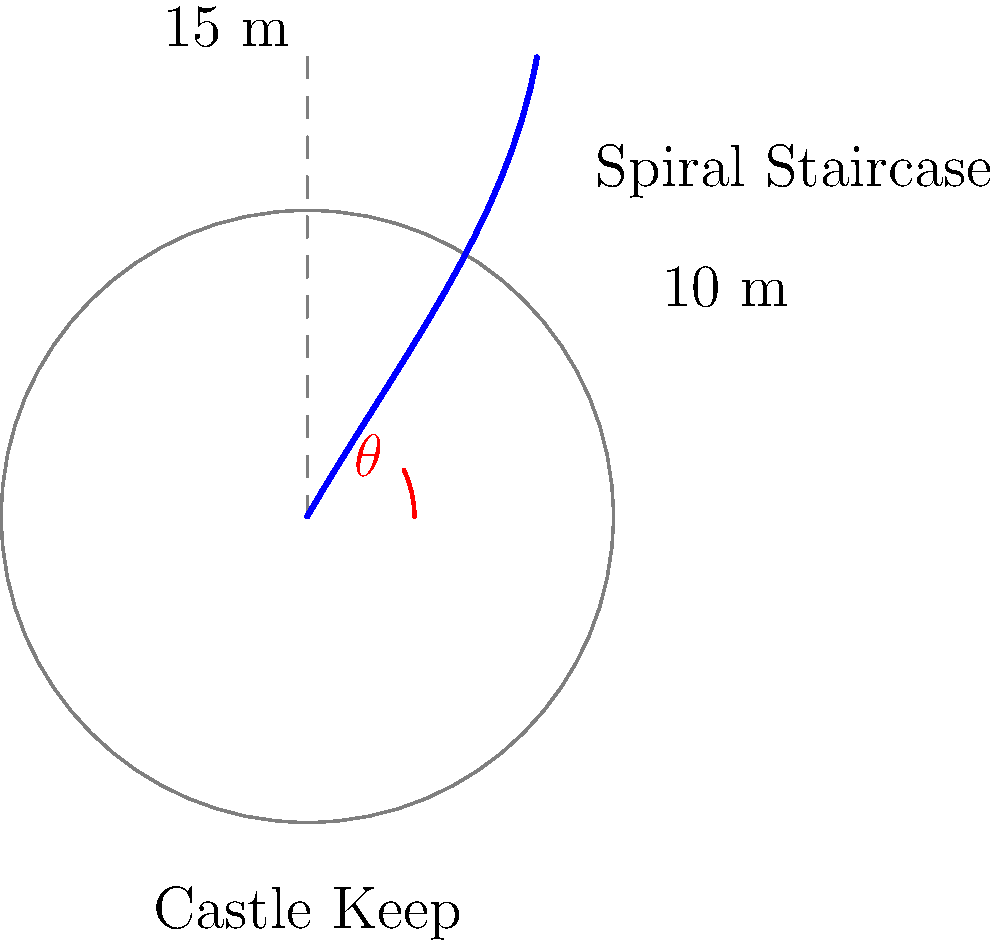In a medieval castle keep, a spiral staircase winds its way up to the top. The staircase makes one complete revolution around the circular keep, which has a circumference of 10 meters. If the height of the keep is 15 meters, what is the angle $\theta$ (in degrees) that the staircase makes with the horizontal plane? To solve this problem, we need to visualize the spiral staircase as if it were "unwound" into a right triangle. Let's approach this step-by-step:

1) In this right triangle:
   - The base represents the circumference of the keep (10 m)
   - The height represents the vertical distance (15 m)
   - The hypotenuse represents the unwound staircase
   - The angle $\theta$ is what we're looking for

2) We can use the arctangent function to find this angle. In a right triangle:

   $\tan(\theta) = \frac{\text{opposite}}{\text{adjacent}} = \frac{\text{height}}{\text{circumference}}$

3) Plugging in our values:

   $\tan(\theta) = \frac{15}{10} = 1.5$

4) To find $\theta$, we take the inverse tangent (arctangent) of both sides:

   $\theta = \arctan(1.5)$

5) Using a calculator or trigonometric tables:

   $\theta \approx 56.31^\circ$

6) Round to the nearest degree:

   $\theta \approx 56^\circ$

This angle represents the inclination of the spiral staircase with respect to the horizontal plane.
Answer: $56^\circ$ 